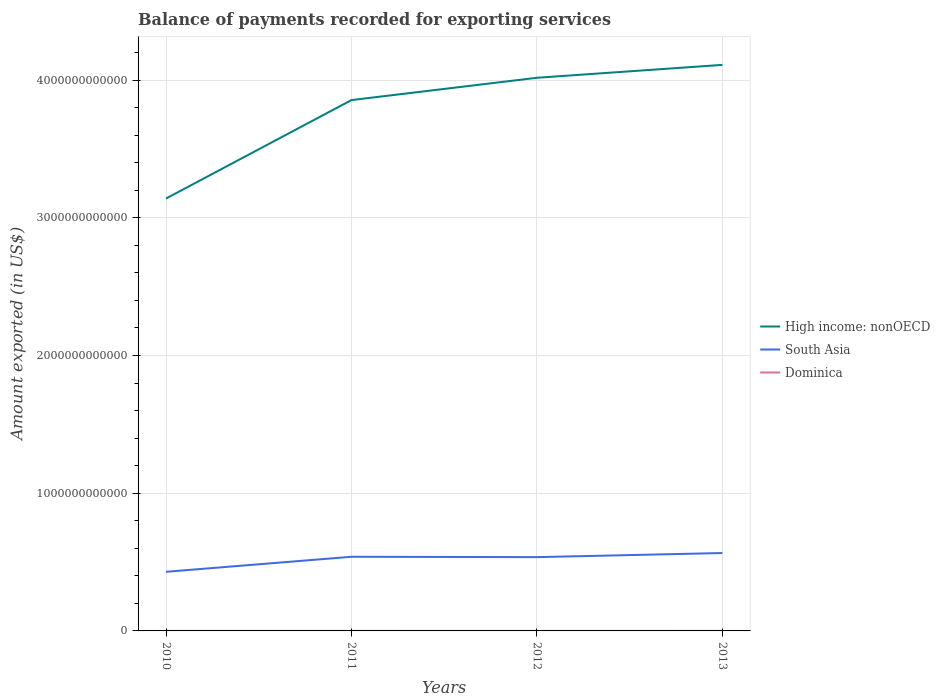Across all years, what is the maximum amount exported in South Asia?
Provide a succinct answer. 4.29e+11. What is the total amount exported in Dominica in the graph?
Offer a very short reply. -9.22e+06. What is the difference between the highest and the second highest amount exported in High income: nonOECD?
Ensure brevity in your answer.  9.70e+11. How many lines are there?
Give a very brief answer. 3. What is the difference between two consecutive major ticks on the Y-axis?
Keep it short and to the point. 1.00e+12. Are the values on the major ticks of Y-axis written in scientific E-notation?
Give a very brief answer. No. Does the graph contain any zero values?
Your answer should be very brief. No. Where does the legend appear in the graph?
Keep it short and to the point. Center right. How are the legend labels stacked?
Make the answer very short. Vertical. What is the title of the graph?
Offer a very short reply. Balance of payments recorded for exporting services. What is the label or title of the X-axis?
Give a very brief answer. Years. What is the label or title of the Y-axis?
Give a very brief answer. Amount exported (in US$). What is the Amount exported (in US$) of High income: nonOECD in 2010?
Your answer should be very brief. 3.14e+12. What is the Amount exported (in US$) of South Asia in 2010?
Offer a terse response. 4.29e+11. What is the Amount exported (in US$) in Dominica in 2010?
Make the answer very short. 1.80e+08. What is the Amount exported (in US$) of High income: nonOECD in 2011?
Make the answer very short. 3.85e+12. What is the Amount exported (in US$) in South Asia in 2011?
Offer a terse response. 5.38e+11. What is the Amount exported (in US$) in Dominica in 2011?
Ensure brevity in your answer.  1.96e+08. What is the Amount exported (in US$) of High income: nonOECD in 2012?
Offer a terse response. 4.02e+12. What is the Amount exported (in US$) in South Asia in 2012?
Give a very brief answer. 5.36e+11. What is the Amount exported (in US$) of Dominica in 2012?
Ensure brevity in your answer.  1.65e+08. What is the Amount exported (in US$) in High income: nonOECD in 2013?
Give a very brief answer. 4.11e+12. What is the Amount exported (in US$) of South Asia in 2013?
Make the answer very short. 5.66e+11. What is the Amount exported (in US$) in Dominica in 2013?
Your answer should be compact. 1.74e+08. Across all years, what is the maximum Amount exported (in US$) of High income: nonOECD?
Your answer should be compact. 4.11e+12. Across all years, what is the maximum Amount exported (in US$) of South Asia?
Offer a very short reply. 5.66e+11. Across all years, what is the maximum Amount exported (in US$) in Dominica?
Offer a terse response. 1.96e+08. Across all years, what is the minimum Amount exported (in US$) of High income: nonOECD?
Make the answer very short. 3.14e+12. Across all years, what is the minimum Amount exported (in US$) of South Asia?
Ensure brevity in your answer.  4.29e+11. Across all years, what is the minimum Amount exported (in US$) in Dominica?
Give a very brief answer. 1.65e+08. What is the total Amount exported (in US$) of High income: nonOECD in the graph?
Offer a terse response. 1.51e+13. What is the total Amount exported (in US$) in South Asia in the graph?
Ensure brevity in your answer.  2.07e+12. What is the total Amount exported (in US$) of Dominica in the graph?
Your answer should be very brief. 7.15e+08. What is the difference between the Amount exported (in US$) in High income: nonOECD in 2010 and that in 2011?
Make the answer very short. -7.15e+11. What is the difference between the Amount exported (in US$) of South Asia in 2010 and that in 2011?
Keep it short and to the point. -1.09e+11. What is the difference between the Amount exported (in US$) in Dominica in 2010 and that in 2011?
Ensure brevity in your answer.  -1.57e+07. What is the difference between the Amount exported (in US$) of High income: nonOECD in 2010 and that in 2012?
Ensure brevity in your answer.  -8.77e+11. What is the difference between the Amount exported (in US$) in South Asia in 2010 and that in 2012?
Offer a very short reply. -1.06e+11. What is the difference between the Amount exported (in US$) in Dominica in 2010 and that in 2012?
Ensure brevity in your answer.  1.51e+07. What is the difference between the Amount exported (in US$) of High income: nonOECD in 2010 and that in 2013?
Make the answer very short. -9.70e+11. What is the difference between the Amount exported (in US$) of South Asia in 2010 and that in 2013?
Offer a terse response. -1.36e+11. What is the difference between the Amount exported (in US$) of Dominica in 2010 and that in 2013?
Your answer should be compact. 5.88e+06. What is the difference between the Amount exported (in US$) in High income: nonOECD in 2011 and that in 2012?
Keep it short and to the point. -1.62e+11. What is the difference between the Amount exported (in US$) of South Asia in 2011 and that in 2012?
Your answer should be very brief. 2.76e+09. What is the difference between the Amount exported (in US$) of Dominica in 2011 and that in 2012?
Your response must be concise. 3.08e+07. What is the difference between the Amount exported (in US$) of High income: nonOECD in 2011 and that in 2013?
Offer a very short reply. -2.56e+11. What is the difference between the Amount exported (in US$) in South Asia in 2011 and that in 2013?
Offer a very short reply. -2.72e+1. What is the difference between the Amount exported (in US$) in Dominica in 2011 and that in 2013?
Keep it short and to the point. 2.16e+07. What is the difference between the Amount exported (in US$) in High income: nonOECD in 2012 and that in 2013?
Your response must be concise. -9.36e+1. What is the difference between the Amount exported (in US$) in South Asia in 2012 and that in 2013?
Ensure brevity in your answer.  -2.99e+1. What is the difference between the Amount exported (in US$) in Dominica in 2012 and that in 2013?
Offer a terse response. -9.22e+06. What is the difference between the Amount exported (in US$) of High income: nonOECD in 2010 and the Amount exported (in US$) of South Asia in 2011?
Offer a terse response. 2.60e+12. What is the difference between the Amount exported (in US$) of High income: nonOECD in 2010 and the Amount exported (in US$) of Dominica in 2011?
Your answer should be compact. 3.14e+12. What is the difference between the Amount exported (in US$) of South Asia in 2010 and the Amount exported (in US$) of Dominica in 2011?
Your answer should be compact. 4.29e+11. What is the difference between the Amount exported (in US$) in High income: nonOECD in 2010 and the Amount exported (in US$) in South Asia in 2012?
Ensure brevity in your answer.  2.60e+12. What is the difference between the Amount exported (in US$) in High income: nonOECD in 2010 and the Amount exported (in US$) in Dominica in 2012?
Your answer should be very brief. 3.14e+12. What is the difference between the Amount exported (in US$) in South Asia in 2010 and the Amount exported (in US$) in Dominica in 2012?
Make the answer very short. 4.29e+11. What is the difference between the Amount exported (in US$) of High income: nonOECD in 2010 and the Amount exported (in US$) of South Asia in 2013?
Offer a very short reply. 2.57e+12. What is the difference between the Amount exported (in US$) in High income: nonOECD in 2010 and the Amount exported (in US$) in Dominica in 2013?
Your response must be concise. 3.14e+12. What is the difference between the Amount exported (in US$) in South Asia in 2010 and the Amount exported (in US$) in Dominica in 2013?
Give a very brief answer. 4.29e+11. What is the difference between the Amount exported (in US$) of High income: nonOECD in 2011 and the Amount exported (in US$) of South Asia in 2012?
Your answer should be compact. 3.32e+12. What is the difference between the Amount exported (in US$) in High income: nonOECD in 2011 and the Amount exported (in US$) in Dominica in 2012?
Keep it short and to the point. 3.85e+12. What is the difference between the Amount exported (in US$) of South Asia in 2011 and the Amount exported (in US$) of Dominica in 2012?
Your answer should be compact. 5.38e+11. What is the difference between the Amount exported (in US$) of High income: nonOECD in 2011 and the Amount exported (in US$) of South Asia in 2013?
Your response must be concise. 3.29e+12. What is the difference between the Amount exported (in US$) of High income: nonOECD in 2011 and the Amount exported (in US$) of Dominica in 2013?
Give a very brief answer. 3.85e+12. What is the difference between the Amount exported (in US$) in South Asia in 2011 and the Amount exported (in US$) in Dominica in 2013?
Your answer should be very brief. 5.38e+11. What is the difference between the Amount exported (in US$) of High income: nonOECD in 2012 and the Amount exported (in US$) of South Asia in 2013?
Your answer should be very brief. 3.45e+12. What is the difference between the Amount exported (in US$) in High income: nonOECD in 2012 and the Amount exported (in US$) in Dominica in 2013?
Offer a terse response. 4.02e+12. What is the difference between the Amount exported (in US$) of South Asia in 2012 and the Amount exported (in US$) of Dominica in 2013?
Offer a terse response. 5.36e+11. What is the average Amount exported (in US$) of High income: nonOECD per year?
Make the answer very short. 3.78e+12. What is the average Amount exported (in US$) of South Asia per year?
Keep it short and to the point. 5.17e+11. What is the average Amount exported (in US$) in Dominica per year?
Offer a very short reply. 1.79e+08. In the year 2010, what is the difference between the Amount exported (in US$) in High income: nonOECD and Amount exported (in US$) in South Asia?
Provide a succinct answer. 2.71e+12. In the year 2010, what is the difference between the Amount exported (in US$) of High income: nonOECD and Amount exported (in US$) of Dominica?
Offer a very short reply. 3.14e+12. In the year 2010, what is the difference between the Amount exported (in US$) in South Asia and Amount exported (in US$) in Dominica?
Provide a succinct answer. 4.29e+11. In the year 2011, what is the difference between the Amount exported (in US$) in High income: nonOECD and Amount exported (in US$) in South Asia?
Make the answer very short. 3.32e+12. In the year 2011, what is the difference between the Amount exported (in US$) in High income: nonOECD and Amount exported (in US$) in Dominica?
Your answer should be very brief. 3.85e+12. In the year 2011, what is the difference between the Amount exported (in US$) in South Asia and Amount exported (in US$) in Dominica?
Give a very brief answer. 5.38e+11. In the year 2012, what is the difference between the Amount exported (in US$) in High income: nonOECD and Amount exported (in US$) in South Asia?
Ensure brevity in your answer.  3.48e+12. In the year 2012, what is the difference between the Amount exported (in US$) of High income: nonOECD and Amount exported (in US$) of Dominica?
Provide a short and direct response. 4.02e+12. In the year 2012, what is the difference between the Amount exported (in US$) in South Asia and Amount exported (in US$) in Dominica?
Keep it short and to the point. 5.36e+11. In the year 2013, what is the difference between the Amount exported (in US$) of High income: nonOECD and Amount exported (in US$) of South Asia?
Your response must be concise. 3.54e+12. In the year 2013, what is the difference between the Amount exported (in US$) in High income: nonOECD and Amount exported (in US$) in Dominica?
Provide a short and direct response. 4.11e+12. In the year 2013, what is the difference between the Amount exported (in US$) of South Asia and Amount exported (in US$) of Dominica?
Ensure brevity in your answer.  5.65e+11. What is the ratio of the Amount exported (in US$) in High income: nonOECD in 2010 to that in 2011?
Offer a very short reply. 0.81. What is the ratio of the Amount exported (in US$) in South Asia in 2010 to that in 2011?
Give a very brief answer. 0.8. What is the ratio of the Amount exported (in US$) of Dominica in 2010 to that in 2011?
Your answer should be compact. 0.92. What is the ratio of the Amount exported (in US$) of High income: nonOECD in 2010 to that in 2012?
Keep it short and to the point. 0.78. What is the ratio of the Amount exported (in US$) of South Asia in 2010 to that in 2012?
Keep it short and to the point. 0.8. What is the ratio of the Amount exported (in US$) of Dominica in 2010 to that in 2012?
Give a very brief answer. 1.09. What is the ratio of the Amount exported (in US$) in High income: nonOECD in 2010 to that in 2013?
Provide a short and direct response. 0.76. What is the ratio of the Amount exported (in US$) in South Asia in 2010 to that in 2013?
Your answer should be compact. 0.76. What is the ratio of the Amount exported (in US$) of Dominica in 2010 to that in 2013?
Offer a very short reply. 1.03. What is the ratio of the Amount exported (in US$) of High income: nonOECD in 2011 to that in 2012?
Offer a very short reply. 0.96. What is the ratio of the Amount exported (in US$) of South Asia in 2011 to that in 2012?
Your answer should be very brief. 1.01. What is the ratio of the Amount exported (in US$) of Dominica in 2011 to that in 2012?
Offer a very short reply. 1.19. What is the ratio of the Amount exported (in US$) of High income: nonOECD in 2011 to that in 2013?
Offer a terse response. 0.94. What is the ratio of the Amount exported (in US$) in South Asia in 2011 to that in 2013?
Your response must be concise. 0.95. What is the ratio of the Amount exported (in US$) in Dominica in 2011 to that in 2013?
Ensure brevity in your answer.  1.12. What is the ratio of the Amount exported (in US$) of High income: nonOECD in 2012 to that in 2013?
Provide a succinct answer. 0.98. What is the ratio of the Amount exported (in US$) of South Asia in 2012 to that in 2013?
Ensure brevity in your answer.  0.95. What is the ratio of the Amount exported (in US$) of Dominica in 2012 to that in 2013?
Give a very brief answer. 0.95. What is the difference between the highest and the second highest Amount exported (in US$) in High income: nonOECD?
Provide a succinct answer. 9.36e+1. What is the difference between the highest and the second highest Amount exported (in US$) in South Asia?
Provide a short and direct response. 2.72e+1. What is the difference between the highest and the second highest Amount exported (in US$) of Dominica?
Give a very brief answer. 1.57e+07. What is the difference between the highest and the lowest Amount exported (in US$) of High income: nonOECD?
Offer a terse response. 9.70e+11. What is the difference between the highest and the lowest Amount exported (in US$) of South Asia?
Provide a short and direct response. 1.36e+11. What is the difference between the highest and the lowest Amount exported (in US$) of Dominica?
Offer a terse response. 3.08e+07. 